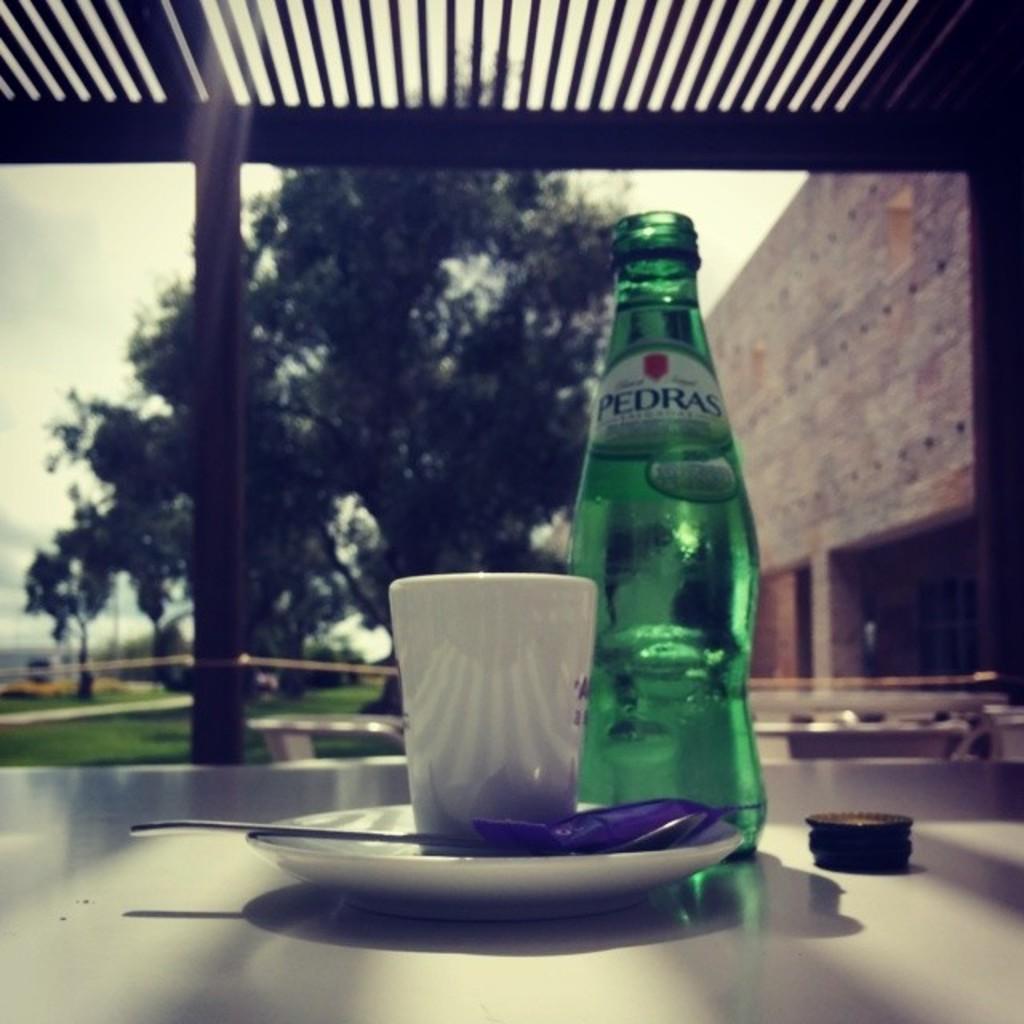Could you give a brief overview of what you see in this image? There is a table which has a drink bottle and a cup on it and there is a building and trees in the background. 